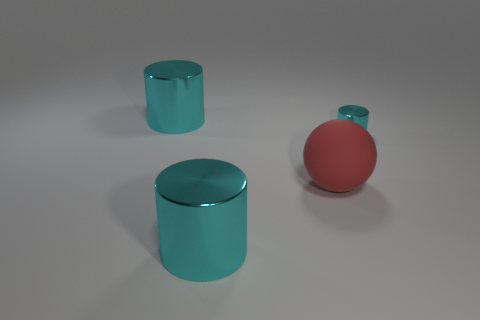Are there any other things that are the same shape as the large rubber thing?
Your answer should be very brief. No. Is there any other thing that is the same material as the red object?
Provide a short and direct response. No. How many other rubber things are the same shape as the big red object?
Offer a terse response. 0. There is a large metallic cylinder in front of the large cyan metallic cylinder behind the red rubber ball; are there any rubber spheres to the left of it?
Your answer should be compact. No. Is the size of the cyan metal cylinder right of the red rubber ball the same as the large red rubber thing?
Give a very brief answer. No. What number of metal cylinders are the same size as the red matte sphere?
Your answer should be compact. 2. Does the large rubber sphere have the same color as the small cylinder?
Give a very brief answer. No. The tiny cyan thing has what shape?
Provide a succinct answer. Cylinder. Are there any other rubber spheres that have the same color as the big matte ball?
Your response must be concise. No. Are there more matte objects left of the red thing than big objects?
Your answer should be compact. No. 